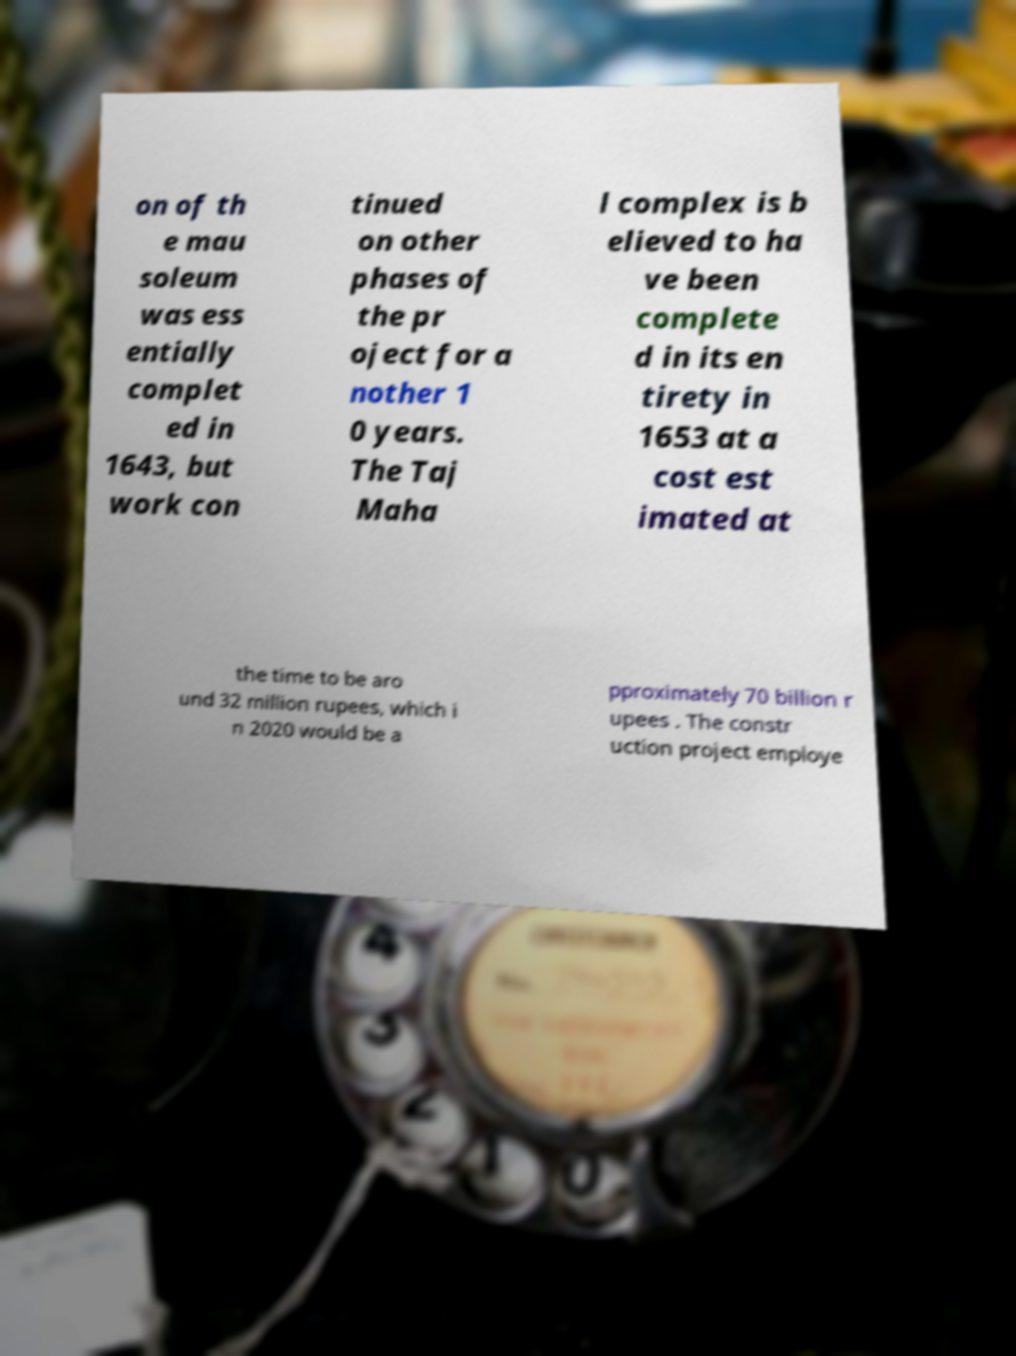Could you assist in decoding the text presented in this image and type it out clearly? on of th e mau soleum was ess entially complet ed in 1643, but work con tinued on other phases of the pr oject for a nother 1 0 years. The Taj Maha l complex is b elieved to ha ve been complete d in its en tirety in 1653 at a cost est imated at the time to be aro und 32 million rupees, which i n 2020 would be a pproximately 70 billion r upees . The constr uction project employe 